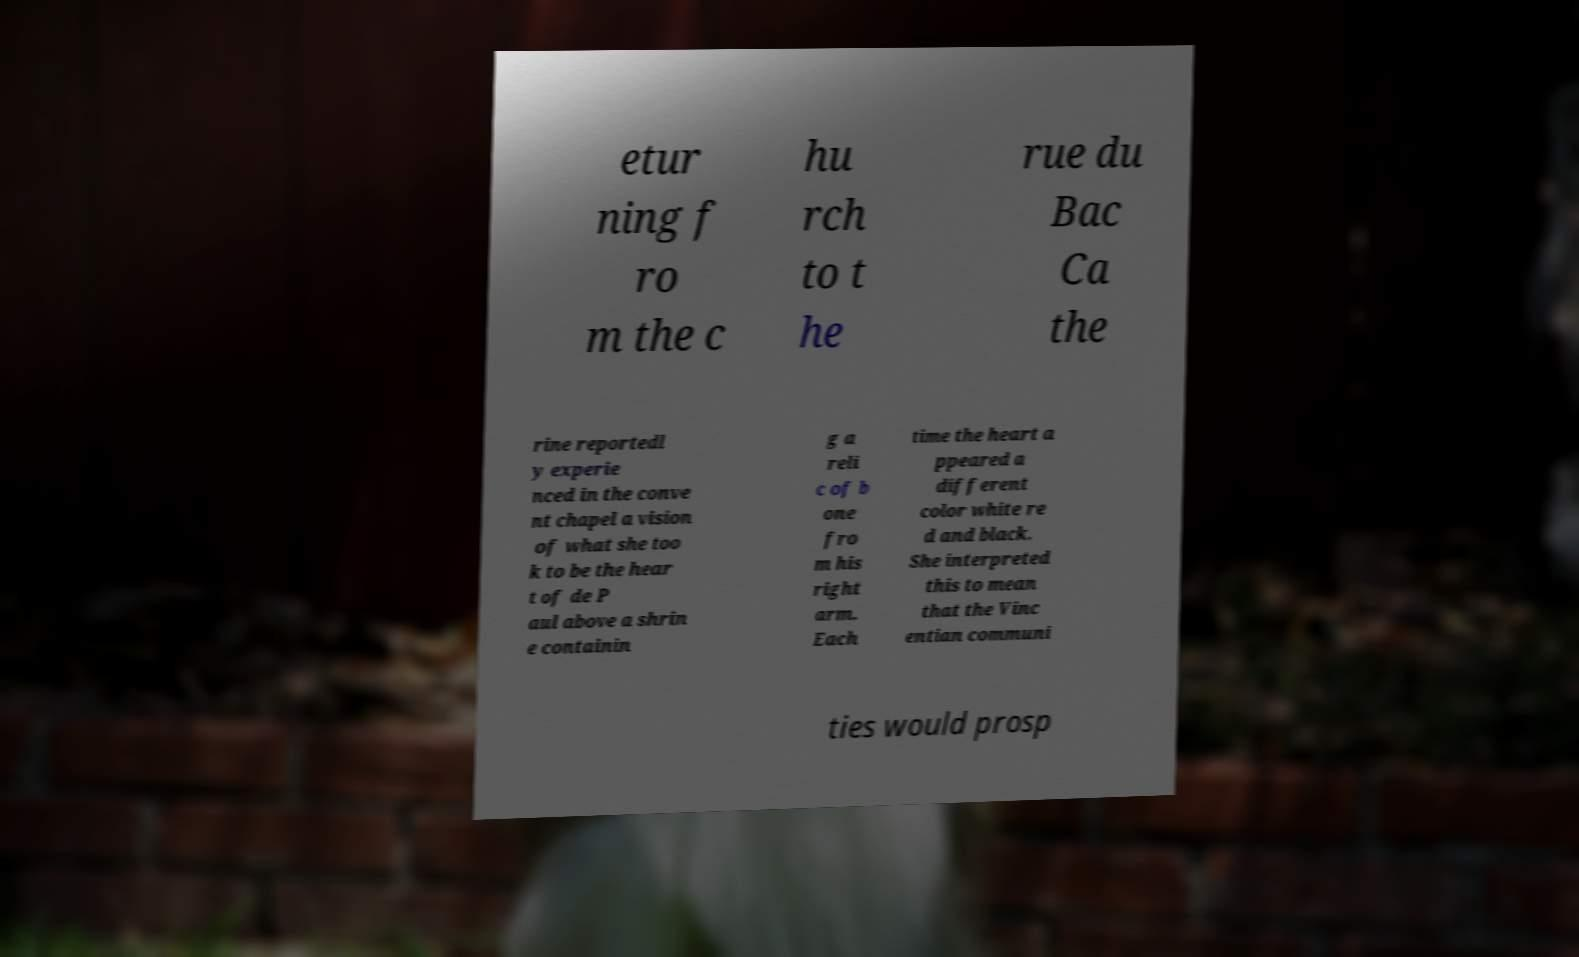Could you assist in decoding the text presented in this image and type it out clearly? etur ning f ro m the c hu rch to t he rue du Bac Ca the rine reportedl y experie nced in the conve nt chapel a vision of what she too k to be the hear t of de P aul above a shrin e containin g a reli c of b one fro m his right arm. Each time the heart a ppeared a different color white re d and black. She interpreted this to mean that the Vinc entian communi ties would prosp 